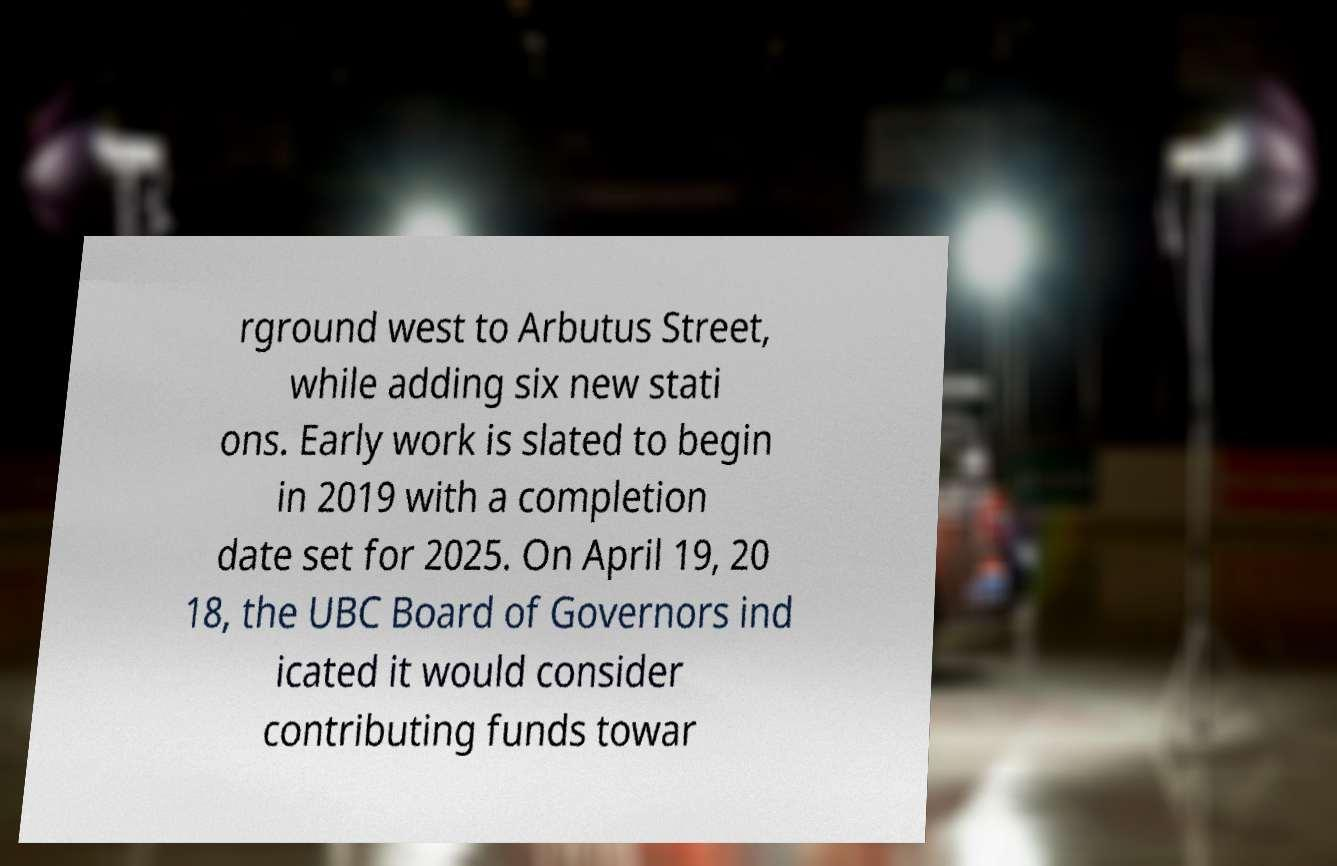There's text embedded in this image that I need extracted. Can you transcribe it verbatim? rground west to Arbutus Street, while adding six new stati ons. Early work is slated to begin in 2019 with a completion date set for 2025. On April 19, 20 18, the UBC Board of Governors ind icated it would consider contributing funds towar 